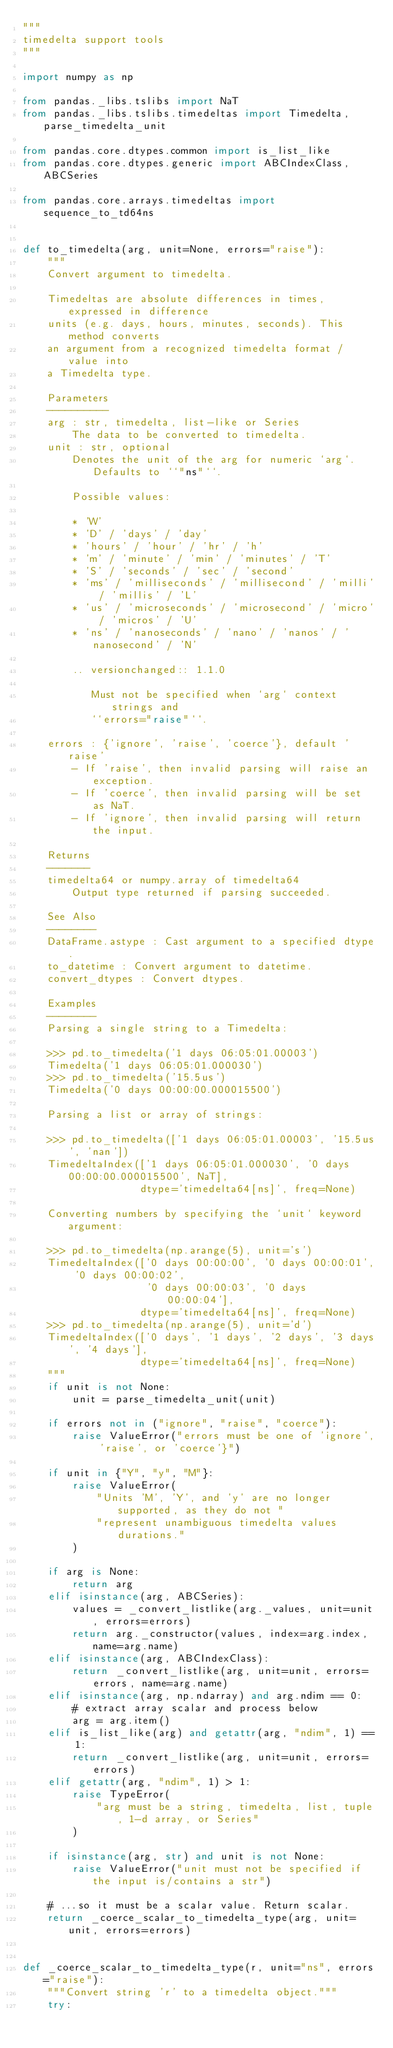<code> <loc_0><loc_0><loc_500><loc_500><_Python_>"""
timedelta support tools
"""

import numpy as np

from pandas._libs.tslibs import NaT
from pandas._libs.tslibs.timedeltas import Timedelta, parse_timedelta_unit

from pandas.core.dtypes.common import is_list_like
from pandas.core.dtypes.generic import ABCIndexClass, ABCSeries

from pandas.core.arrays.timedeltas import sequence_to_td64ns


def to_timedelta(arg, unit=None, errors="raise"):
    """
    Convert argument to timedelta.

    Timedeltas are absolute differences in times, expressed in difference
    units (e.g. days, hours, minutes, seconds). This method converts
    an argument from a recognized timedelta format / value into
    a Timedelta type.

    Parameters
    ----------
    arg : str, timedelta, list-like or Series
        The data to be converted to timedelta.
    unit : str, optional
        Denotes the unit of the arg for numeric `arg`. Defaults to ``"ns"``.

        Possible values:

        * 'W'
        * 'D' / 'days' / 'day'
        * 'hours' / 'hour' / 'hr' / 'h'
        * 'm' / 'minute' / 'min' / 'minutes' / 'T'
        * 'S' / 'seconds' / 'sec' / 'second'
        * 'ms' / 'milliseconds' / 'millisecond' / 'milli' / 'millis' / 'L'
        * 'us' / 'microseconds' / 'microsecond' / 'micro' / 'micros' / 'U'
        * 'ns' / 'nanoseconds' / 'nano' / 'nanos' / 'nanosecond' / 'N'

        .. versionchanged:: 1.1.0

           Must not be specified when `arg` context strings and
           ``errors="raise"``.

    errors : {'ignore', 'raise', 'coerce'}, default 'raise'
        - If 'raise', then invalid parsing will raise an exception.
        - If 'coerce', then invalid parsing will be set as NaT.
        - If 'ignore', then invalid parsing will return the input.

    Returns
    -------
    timedelta64 or numpy.array of timedelta64
        Output type returned if parsing succeeded.

    See Also
    --------
    DataFrame.astype : Cast argument to a specified dtype.
    to_datetime : Convert argument to datetime.
    convert_dtypes : Convert dtypes.

    Examples
    --------
    Parsing a single string to a Timedelta:

    >>> pd.to_timedelta('1 days 06:05:01.00003')
    Timedelta('1 days 06:05:01.000030')
    >>> pd.to_timedelta('15.5us')
    Timedelta('0 days 00:00:00.000015500')

    Parsing a list or array of strings:

    >>> pd.to_timedelta(['1 days 06:05:01.00003', '15.5us', 'nan'])
    TimedeltaIndex(['1 days 06:05:01.000030', '0 days 00:00:00.000015500', NaT],
                   dtype='timedelta64[ns]', freq=None)

    Converting numbers by specifying the `unit` keyword argument:

    >>> pd.to_timedelta(np.arange(5), unit='s')
    TimedeltaIndex(['0 days 00:00:00', '0 days 00:00:01', '0 days 00:00:02',
                    '0 days 00:00:03', '0 days 00:00:04'],
                   dtype='timedelta64[ns]', freq=None)
    >>> pd.to_timedelta(np.arange(5), unit='d')
    TimedeltaIndex(['0 days', '1 days', '2 days', '3 days', '4 days'],
                   dtype='timedelta64[ns]', freq=None)
    """
    if unit is not None:
        unit = parse_timedelta_unit(unit)

    if errors not in ("ignore", "raise", "coerce"):
        raise ValueError("errors must be one of 'ignore', 'raise', or 'coerce'}")

    if unit in {"Y", "y", "M"}:
        raise ValueError(
            "Units 'M', 'Y', and 'y' are no longer supported, as they do not "
            "represent unambiguous timedelta values durations."
        )

    if arg is None:
        return arg
    elif isinstance(arg, ABCSeries):
        values = _convert_listlike(arg._values, unit=unit, errors=errors)
        return arg._constructor(values, index=arg.index, name=arg.name)
    elif isinstance(arg, ABCIndexClass):
        return _convert_listlike(arg, unit=unit, errors=errors, name=arg.name)
    elif isinstance(arg, np.ndarray) and arg.ndim == 0:
        # extract array scalar and process below
        arg = arg.item()
    elif is_list_like(arg) and getattr(arg, "ndim", 1) == 1:
        return _convert_listlike(arg, unit=unit, errors=errors)
    elif getattr(arg, "ndim", 1) > 1:
        raise TypeError(
            "arg must be a string, timedelta, list, tuple, 1-d array, or Series"
        )

    if isinstance(arg, str) and unit is not None:
        raise ValueError("unit must not be specified if the input is/contains a str")

    # ...so it must be a scalar value. Return scalar.
    return _coerce_scalar_to_timedelta_type(arg, unit=unit, errors=errors)


def _coerce_scalar_to_timedelta_type(r, unit="ns", errors="raise"):
    """Convert string 'r' to a timedelta object."""
    try:</code> 